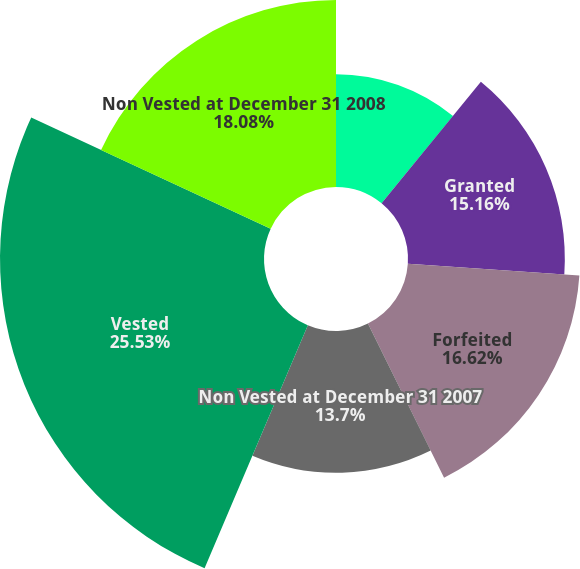Convert chart to OTSL. <chart><loc_0><loc_0><loc_500><loc_500><pie_chart><fcel>Non Vested at January 1 2007<fcel>Granted<fcel>Forfeited<fcel>Non Vested at December 31 2007<fcel>Vested<fcel>Non Vested at December 31 2008<nl><fcel>10.91%<fcel>15.16%<fcel>16.62%<fcel>13.7%<fcel>25.52%<fcel>18.08%<nl></chart> 